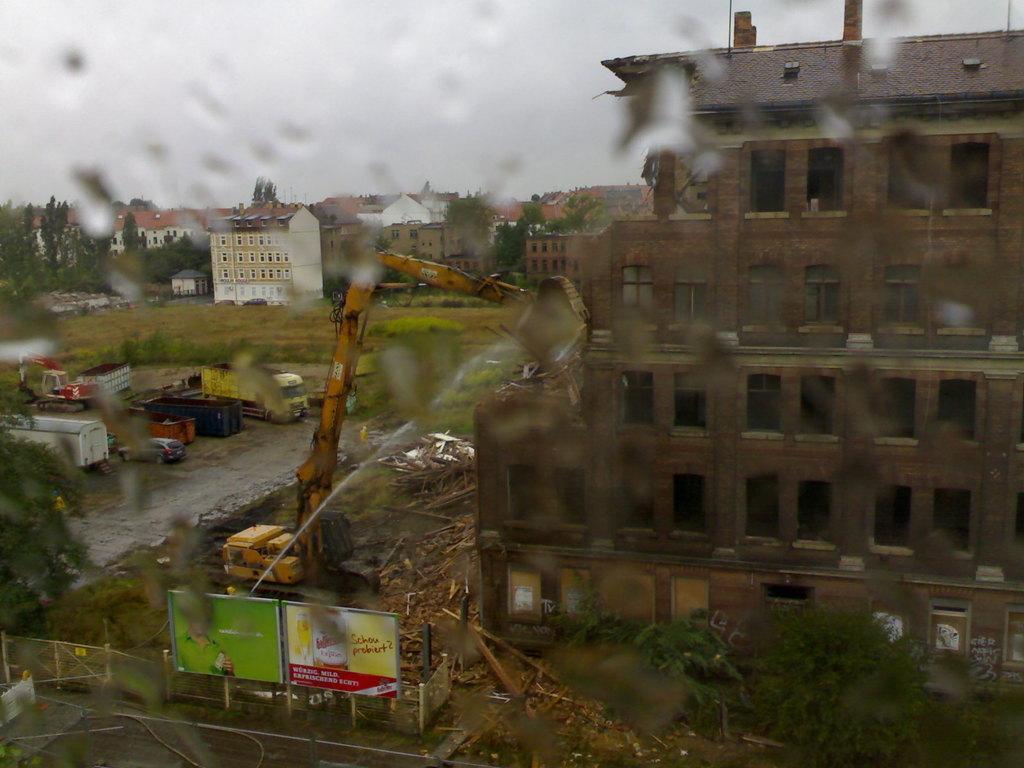Could you give a brief overview of what you see in this image? In the image we can see a glass. Through the glass we can see some vehicles, buildings, trees and banners and grass. At the top of the image there is sky. 